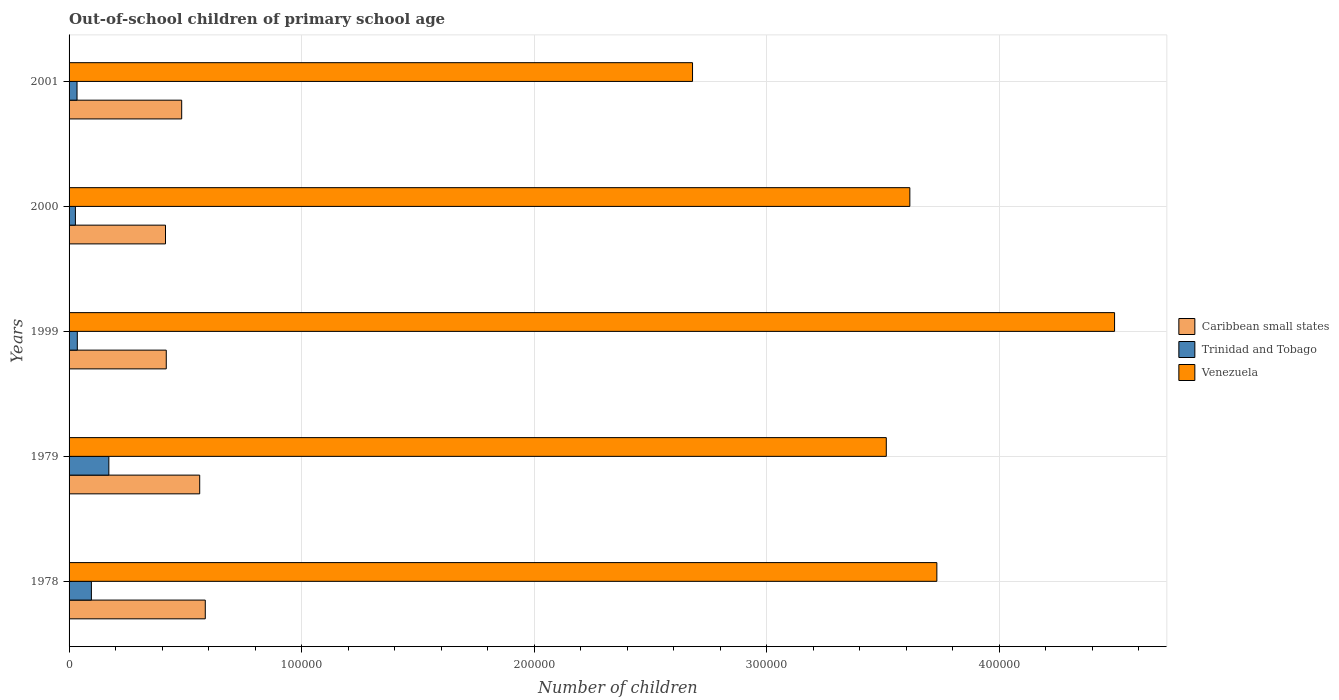How many different coloured bars are there?
Provide a succinct answer. 3. How many bars are there on the 4th tick from the top?
Give a very brief answer. 3. How many bars are there on the 5th tick from the bottom?
Ensure brevity in your answer.  3. What is the label of the 2nd group of bars from the top?
Give a very brief answer. 2000. What is the number of out-of-school children in Trinidad and Tobago in 2000?
Keep it short and to the point. 2723. Across all years, what is the maximum number of out-of-school children in Caribbean small states?
Give a very brief answer. 5.86e+04. Across all years, what is the minimum number of out-of-school children in Caribbean small states?
Your response must be concise. 4.15e+04. In which year was the number of out-of-school children in Venezuela maximum?
Offer a very short reply. 1999. In which year was the number of out-of-school children in Venezuela minimum?
Provide a succinct answer. 2001. What is the total number of out-of-school children in Trinidad and Tobago in the graph?
Ensure brevity in your answer.  3.64e+04. What is the difference between the number of out-of-school children in Venezuela in 1978 and that in 2001?
Keep it short and to the point. 1.05e+05. What is the difference between the number of out-of-school children in Trinidad and Tobago in 1979 and the number of out-of-school children in Venezuela in 2000?
Make the answer very short. -3.44e+05. What is the average number of out-of-school children in Venezuela per year?
Ensure brevity in your answer.  3.61e+05. In the year 1999, what is the difference between the number of out-of-school children in Caribbean small states and number of out-of-school children in Venezuela?
Give a very brief answer. -4.08e+05. What is the ratio of the number of out-of-school children in Caribbean small states in 2000 to that in 2001?
Provide a succinct answer. 0.86. What is the difference between the highest and the second highest number of out-of-school children in Venezuela?
Ensure brevity in your answer.  7.64e+04. What is the difference between the highest and the lowest number of out-of-school children in Trinidad and Tobago?
Provide a short and direct response. 1.44e+04. In how many years, is the number of out-of-school children in Trinidad and Tobago greater than the average number of out-of-school children in Trinidad and Tobago taken over all years?
Your answer should be compact. 2. Is the sum of the number of out-of-school children in Caribbean small states in 1979 and 2001 greater than the maximum number of out-of-school children in Venezuela across all years?
Your answer should be very brief. No. What does the 3rd bar from the top in 1999 represents?
Provide a succinct answer. Caribbean small states. What does the 2nd bar from the bottom in 1999 represents?
Provide a short and direct response. Trinidad and Tobago. How many bars are there?
Keep it short and to the point. 15. What is the difference between two consecutive major ticks on the X-axis?
Ensure brevity in your answer.  1.00e+05. Are the values on the major ticks of X-axis written in scientific E-notation?
Offer a very short reply. No. Does the graph contain any zero values?
Offer a terse response. No. Does the graph contain grids?
Provide a short and direct response. Yes. Where does the legend appear in the graph?
Your response must be concise. Center right. How many legend labels are there?
Offer a terse response. 3. How are the legend labels stacked?
Ensure brevity in your answer.  Vertical. What is the title of the graph?
Keep it short and to the point. Out-of-school children of primary school age. What is the label or title of the X-axis?
Keep it short and to the point. Number of children. What is the Number of children in Caribbean small states in 1978?
Keep it short and to the point. 5.86e+04. What is the Number of children in Trinidad and Tobago in 1978?
Provide a succinct answer. 9598. What is the Number of children of Venezuela in 1978?
Offer a very short reply. 3.73e+05. What is the Number of children of Caribbean small states in 1979?
Offer a very short reply. 5.62e+04. What is the Number of children of Trinidad and Tobago in 1979?
Make the answer very short. 1.71e+04. What is the Number of children of Venezuela in 1979?
Ensure brevity in your answer.  3.51e+05. What is the Number of children in Caribbean small states in 1999?
Your answer should be compact. 4.18e+04. What is the Number of children in Trinidad and Tobago in 1999?
Make the answer very short. 3543. What is the Number of children of Venezuela in 1999?
Offer a very short reply. 4.50e+05. What is the Number of children in Caribbean small states in 2000?
Offer a very short reply. 4.15e+04. What is the Number of children in Trinidad and Tobago in 2000?
Ensure brevity in your answer.  2723. What is the Number of children in Venezuela in 2000?
Provide a short and direct response. 3.62e+05. What is the Number of children in Caribbean small states in 2001?
Your answer should be very brief. 4.84e+04. What is the Number of children in Trinidad and Tobago in 2001?
Ensure brevity in your answer.  3425. What is the Number of children of Venezuela in 2001?
Make the answer very short. 2.68e+05. Across all years, what is the maximum Number of children of Caribbean small states?
Offer a terse response. 5.86e+04. Across all years, what is the maximum Number of children of Trinidad and Tobago?
Your response must be concise. 1.71e+04. Across all years, what is the maximum Number of children of Venezuela?
Your answer should be very brief. 4.50e+05. Across all years, what is the minimum Number of children of Caribbean small states?
Your answer should be compact. 4.15e+04. Across all years, what is the minimum Number of children of Trinidad and Tobago?
Ensure brevity in your answer.  2723. Across all years, what is the minimum Number of children in Venezuela?
Your response must be concise. 2.68e+05. What is the total Number of children in Caribbean small states in the graph?
Ensure brevity in your answer.  2.46e+05. What is the total Number of children in Trinidad and Tobago in the graph?
Offer a terse response. 3.64e+04. What is the total Number of children in Venezuela in the graph?
Provide a short and direct response. 1.80e+06. What is the difference between the Number of children of Caribbean small states in 1978 and that in 1979?
Ensure brevity in your answer.  2398. What is the difference between the Number of children of Trinidad and Tobago in 1978 and that in 1979?
Make the answer very short. -7509. What is the difference between the Number of children of Venezuela in 1978 and that in 1979?
Keep it short and to the point. 2.17e+04. What is the difference between the Number of children of Caribbean small states in 1978 and that in 1999?
Offer a very short reply. 1.68e+04. What is the difference between the Number of children in Trinidad and Tobago in 1978 and that in 1999?
Make the answer very short. 6055. What is the difference between the Number of children of Venezuela in 1978 and that in 1999?
Offer a very short reply. -7.64e+04. What is the difference between the Number of children of Caribbean small states in 1978 and that in 2000?
Provide a succinct answer. 1.71e+04. What is the difference between the Number of children in Trinidad and Tobago in 1978 and that in 2000?
Make the answer very short. 6875. What is the difference between the Number of children in Venezuela in 1978 and that in 2000?
Make the answer very short. 1.16e+04. What is the difference between the Number of children in Caribbean small states in 1978 and that in 2001?
Give a very brief answer. 1.01e+04. What is the difference between the Number of children of Trinidad and Tobago in 1978 and that in 2001?
Offer a terse response. 6173. What is the difference between the Number of children of Venezuela in 1978 and that in 2001?
Make the answer very short. 1.05e+05. What is the difference between the Number of children of Caribbean small states in 1979 and that in 1999?
Keep it short and to the point. 1.44e+04. What is the difference between the Number of children of Trinidad and Tobago in 1979 and that in 1999?
Make the answer very short. 1.36e+04. What is the difference between the Number of children of Venezuela in 1979 and that in 1999?
Give a very brief answer. -9.82e+04. What is the difference between the Number of children in Caribbean small states in 1979 and that in 2000?
Ensure brevity in your answer.  1.47e+04. What is the difference between the Number of children of Trinidad and Tobago in 1979 and that in 2000?
Provide a succinct answer. 1.44e+04. What is the difference between the Number of children of Venezuela in 1979 and that in 2000?
Give a very brief answer. -1.01e+04. What is the difference between the Number of children in Caribbean small states in 1979 and that in 2001?
Give a very brief answer. 7748. What is the difference between the Number of children in Trinidad and Tobago in 1979 and that in 2001?
Keep it short and to the point. 1.37e+04. What is the difference between the Number of children of Venezuela in 1979 and that in 2001?
Provide a succinct answer. 8.33e+04. What is the difference between the Number of children in Caribbean small states in 1999 and that in 2000?
Your response must be concise. 329. What is the difference between the Number of children of Trinidad and Tobago in 1999 and that in 2000?
Keep it short and to the point. 820. What is the difference between the Number of children of Venezuela in 1999 and that in 2000?
Keep it short and to the point. 8.80e+04. What is the difference between the Number of children of Caribbean small states in 1999 and that in 2001?
Keep it short and to the point. -6627. What is the difference between the Number of children in Trinidad and Tobago in 1999 and that in 2001?
Your answer should be compact. 118. What is the difference between the Number of children of Venezuela in 1999 and that in 2001?
Provide a short and direct response. 1.81e+05. What is the difference between the Number of children of Caribbean small states in 2000 and that in 2001?
Your answer should be compact. -6956. What is the difference between the Number of children in Trinidad and Tobago in 2000 and that in 2001?
Give a very brief answer. -702. What is the difference between the Number of children in Venezuela in 2000 and that in 2001?
Provide a short and direct response. 9.35e+04. What is the difference between the Number of children in Caribbean small states in 1978 and the Number of children in Trinidad and Tobago in 1979?
Ensure brevity in your answer.  4.15e+04. What is the difference between the Number of children in Caribbean small states in 1978 and the Number of children in Venezuela in 1979?
Provide a short and direct response. -2.93e+05. What is the difference between the Number of children of Trinidad and Tobago in 1978 and the Number of children of Venezuela in 1979?
Your response must be concise. -3.42e+05. What is the difference between the Number of children of Caribbean small states in 1978 and the Number of children of Trinidad and Tobago in 1999?
Keep it short and to the point. 5.50e+04. What is the difference between the Number of children in Caribbean small states in 1978 and the Number of children in Venezuela in 1999?
Keep it short and to the point. -3.91e+05. What is the difference between the Number of children of Trinidad and Tobago in 1978 and the Number of children of Venezuela in 1999?
Provide a short and direct response. -4.40e+05. What is the difference between the Number of children in Caribbean small states in 1978 and the Number of children in Trinidad and Tobago in 2000?
Offer a terse response. 5.59e+04. What is the difference between the Number of children of Caribbean small states in 1978 and the Number of children of Venezuela in 2000?
Ensure brevity in your answer.  -3.03e+05. What is the difference between the Number of children of Trinidad and Tobago in 1978 and the Number of children of Venezuela in 2000?
Give a very brief answer. -3.52e+05. What is the difference between the Number of children in Caribbean small states in 1978 and the Number of children in Trinidad and Tobago in 2001?
Your response must be concise. 5.51e+04. What is the difference between the Number of children of Caribbean small states in 1978 and the Number of children of Venezuela in 2001?
Provide a short and direct response. -2.10e+05. What is the difference between the Number of children of Trinidad and Tobago in 1978 and the Number of children of Venezuela in 2001?
Your response must be concise. -2.59e+05. What is the difference between the Number of children in Caribbean small states in 1979 and the Number of children in Trinidad and Tobago in 1999?
Your answer should be very brief. 5.26e+04. What is the difference between the Number of children of Caribbean small states in 1979 and the Number of children of Venezuela in 1999?
Make the answer very short. -3.93e+05. What is the difference between the Number of children of Trinidad and Tobago in 1979 and the Number of children of Venezuela in 1999?
Make the answer very short. -4.33e+05. What is the difference between the Number of children in Caribbean small states in 1979 and the Number of children in Trinidad and Tobago in 2000?
Your response must be concise. 5.35e+04. What is the difference between the Number of children in Caribbean small states in 1979 and the Number of children in Venezuela in 2000?
Your response must be concise. -3.05e+05. What is the difference between the Number of children in Trinidad and Tobago in 1979 and the Number of children in Venezuela in 2000?
Give a very brief answer. -3.44e+05. What is the difference between the Number of children of Caribbean small states in 1979 and the Number of children of Trinidad and Tobago in 2001?
Make the answer very short. 5.28e+04. What is the difference between the Number of children of Caribbean small states in 1979 and the Number of children of Venezuela in 2001?
Offer a terse response. -2.12e+05. What is the difference between the Number of children in Trinidad and Tobago in 1979 and the Number of children in Venezuela in 2001?
Your answer should be compact. -2.51e+05. What is the difference between the Number of children in Caribbean small states in 1999 and the Number of children in Trinidad and Tobago in 2000?
Offer a very short reply. 3.91e+04. What is the difference between the Number of children of Caribbean small states in 1999 and the Number of children of Venezuela in 2000?
Your answer should be compact. -3.20e+05. What is the difference between the Number of children in Trinidad and Tobago in 1999 and the Number of children in Venezuela in 2000?
Ensure brevity in your answer.  -3.58e+05. What is the difference between the Number of children of Caribbean small states in 1999 and the Number of children of Trinidad and Tobago in 2001?
Provide a short and direct response. 3.84e+04. What is the difference between the Number of children of Caribbean small states in 1999 and the Number of children of Venezuela in 2001?
Your response must be concise. -2.26e+05. What is the difference between the Number of children of Trinidad and Tobago in 1999 and the Number of children of Venezuela in 2001?
Your answer should be very brief. -2.65e+05. What is the difference between the Number of children in Caribbean small states in 2000 and the Number of children in Trinidad and Tobago in 2001?
Offer a terse response. 3.80e+04. What is the difference between the Number of children of Caribbean small states in 2000 and the Number of children of Venezuela in 2001?
Provide a short and direct response. -2.27e+05. What is the difference between the Number of children of Trinidad and Tobago in 2000 and the Number of children of Venezuela in 2001?
Your answer should be very brief. -2.65e+05. What is the average Number of children in Caribbean small states per year?
Keep it short and to the point. 4.93e+04. What is the average Number of children of Trinidad and Tobago per year?
Your response must be concise. 7279.2. What is the average Number of children in Venezuela per year?
Offer a terse response. 3.61e+05. In the year 1978, what is the difference between the Number of children of Caribbean small states and Number of children of Trinidad and Tobago?
Your answer should be very brief. 4.90e+04. In the year 1978, what is the difference between the Number of children of Caribbean small states and Number of children of Venezuela?
Ensure brevity in your answer.  -3.15e+05. In the year 1978, what is the difference between the Number of children in Trinidad and Tobago and Number of children in Venezuela?
Keep it short and to the point. -3.64e+05. In the year 1979, what is the difference between the Number of children in Caribbean small states and Number of children in Trinidad and Tobago?
Keep it short and to the point. 3.91e+04. In the year 1979, what is the difference between the Number of children in Caribbean small states and Number of children in Venezuela?
Keep it short and to the point. -2.95e+05. In the year 1979, what is the difference between the Number of children in Trinidad and Tobago and Number of children in Venezuela?
Ensure brevity in your answer.  -3.34e+05. In the year 1999, what is the difference between the Number of children of Caribbean small states and Number of children of Trinidad and Tobago?
Provide a succinct answer. 3.83e+04. In the year 1999, what is the difference between the Number of children of Caribbean small states and Number of children of Venezuela?
Keep it short and to the point. -4.08e+05. In the year 1999, what is the difference between the Number of children of Trinidad and Tobago and Number of children of Venezuela?
Keep it short and to the point. -4.46e+05. In the year 2000, what is the difference between the Number of children in Caribbean small states and Number of children in Trinidad and Tobago?
Ensure brevity in your answer.  3.87e+04. In the year 2000, what is the difference between the Number of children of Caribbean small states and Number of children of Venezuela?
Offer a very short reply. -3.20e+05. In the year 2000, what is the difference between the Number of children in Trinidad and Tobago and Number of children in Venezuela?
Your answer should be very brief. -3.59e+05. In the year 2001, what is the difference between the Number of children of Caribbean small states and Number of children of Trinidad and Tobago?
Provide a succinct answer. 4.50e+04. In the year 2001, what is the difference between the Number of children of Caribbean small states and Number of children of Venezuela?
Give a very brief answer. -2.20e+05. In the year 2001, what is the difference between the Number of children of Trinidad and Tobago and Number of children of Venezuela?
Provide a succinct answer. -2.65e+05. What is the ratio of the Number of children of Caribbean small states in 1978 to that in 1979?
Provide a succinct answer. 1.04. What is the ratio of the Number of children in Trinidad and Tobago in 1978 to that in 1979?
Offer a terse response. 0.56. What is the ratio of the Number of children of Venezuela in 1978 to that in 1979?
Provide a short and direct response. 1.06. What is the ratio of the Number of children of Caribbean small states in 1978 to that in 1999?
Ensure brevity in your answer.  1.4. What is the ratio of the Number of children in Trinidad and Tobago in 1978 to that in 1999?
Your answer should be compact. 2.71. What is the ratio of the Number of children in Venezuela in 1978 to that in 1999?
Ensure brevity in your answer.  0.83. What is the ratio of the Number of children in Caribbean small states in 1978 to that in 2000?
Provide a short and direct response. 1.41. What is the ratio of the Number of children in Trinidad and Tobago in 1978 to that in 2000?
Your response must be concise. 3.52. What is the ratio of the Number of children of Venezuela in 1978 to that in 2000?
Provide a succinct answer. 1.03. What is the ratio of the Number of children in Caribbean small states in 1978 to that in 2001?
Make the answer very short. 1.21. What is the ratio of the Number of children of Trinidad and Tobago in 1978 to that in 2001?
Provide a short and direct response. 2.8. What is the ratio of the Number of children of Venezuela in 1978 to that in 2001?
Keep it short and to the point. 1.39. What is the ratio of the Number of children of Caribbean small states in 1979 to that in 1999?
Offer a very short reply. 1.34. What is the ratio of the Number of children in Trinidad and Tobago in 1979 to that in 1999?
Offer a terse response. 4.83. What is the ratio of the Number of children of Venezuela in 1979 to that in 1999?
Your answer should be compact. 0.78. What is the ratio of the Number of children of Caribbean small states in 1979 to that in 2000?
Provide a succinct answer. 1.35. What is the ratio of the Number of children in Trinidad and Tobago in 1979 to that in 2000?
Your response must be concise. 6.28. What is the ratio of the Number of children of Caribbean small states in 1979 to that in 2001?
Offer a very short reply. 1.16. What is the ratio of the Number of children in Trinidad and Tobago in 1979 to that in 2001?
Offer a terse response. 4.99. What is the ratio of the Number of children in Venezuela in 1979 to that in 2001?
Make the answer very short. 1.31. What is the ratio of the Number of children in Caribbean small states in 1999 to that in 2000?
Make the answer very short. 1.01. What is the ratio of the Number of children of Trinidad and Tobago in 1999 to that in 2000?
Make the answer very short. 1.3. What is the ratio of the Number of children in Venezuela in 1999 to that in 2000?
Provide a short and direct response. 1.24. What is the ratio of the Number of children of Caribbean small states in 1999 to that in 2001?
Your answer should be very brief. 0.86. What is the ratio of the Number of children in Trinidad and Tobago in 1999 to that in 2001?
Offer a terse response. 1.03. What is the ratio of the Number of children of Venezuela in 1999 to that in 2001?
Make the answer very short. 1.68. What is the ratio of the Number of children of Caribbean small states in 2000 to that in 2001?
Your answer should be very brief. 0.86. What is the ratio of the Number of children of Trinidad and Tobago in 2000 to that in 2001?
Provide a short and direct response. 0.8. What is the ratio of the Number of children of Venezuela in 2000 to that in 2001?
Keep it short and to the point. 1.35. What is the difference between the highest and the second highest Number of children of Caribbean small states?
Your answer should be very brief. 2398. What is the difference between the highest and the second highest Number of children in Trinidad and Tobago?
Provide a succinct answer. 7509. What is the difference between the highest and the second highest Number of children in Venezuela?
Your answer should be compact. 7.64e+04. What is the difference between the highest and the lowest Number of children of Caribbean small states?
Offer a very short reply. 1.71e+04. What is the difference between the highest and the lowest Number of children in Trinidad and Tobago?
Keep it short and to the point. 1.44e+04. What is the difference between the highest and the lowest Number of children in Venezuela?
Offer a very short reply. 1.81e+05. 